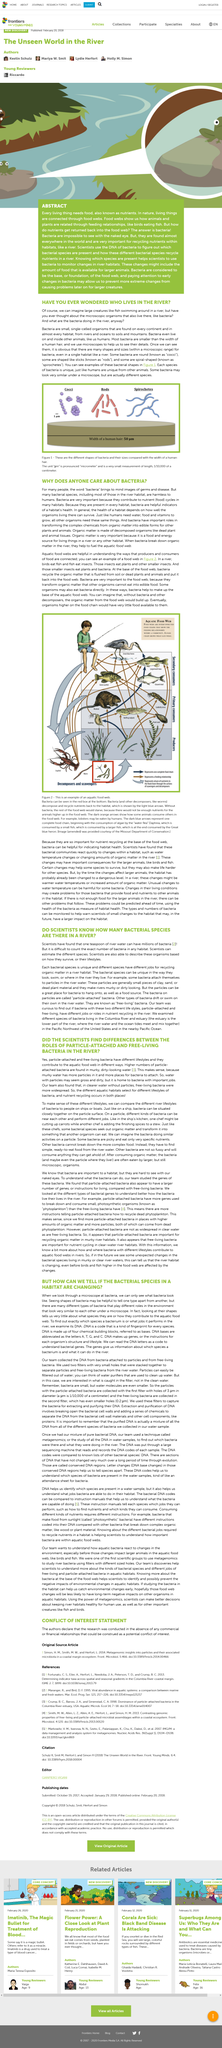Indicate a few pertinent items in this graphic. Yes, most bacteria are smaller than the width of a human hair. Bacteria are microscopic organisms that are found on every continent. They are present on every continent, including Antarctica. Birds eat fish, which is a common type of food for these feathered creatures. Fish feed on a diet consisting primarily of insects. Higher numbers of particle-attached bacteria are commonly found in murky, dirty-looking water, as compared to clear, clean-looking water. 